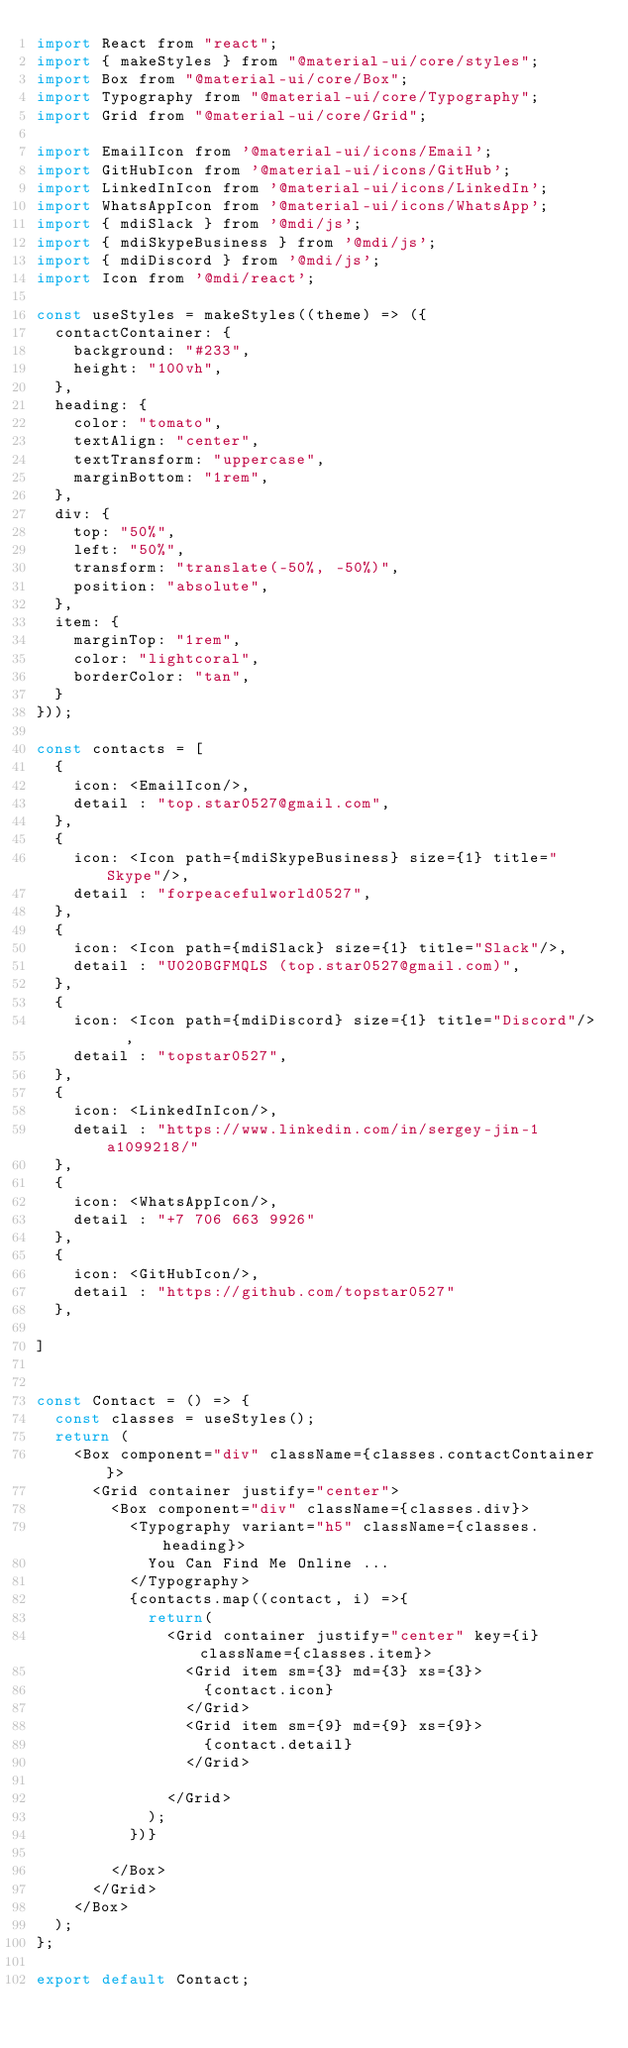<code> <loc_0><loc_0><loc_500><loc_500><_JavaScript_>import React from "react";
import { makeStyles } from "@material-ui/core/styles";
import Box from "@material-ui/core/Box";
import Typography from "@material-ui/core/Typography";
import Grid from "@material-ui/core/Grid";

import EmailIcon from '@material-ui/icons/Email';
import GitHubIcon from '@material-ui/icons/GitHub';
import LinkedInIcon from '@material-ui/icons/LinkedIn';
import WhatsAppIcon from '@material-ui/icons/WhatsApp';
import { mdiSlack } from '@mdi/js';
import { mdiSkypeBusiness } from '@mdi/js';
import { mdiDiscord } from '@mdi/js';
import Icon from '@mdi/react';

const useStyles = makeStyles((theme) => ({
  contactContainer: {
    background: "#233",
    height: "100vh",
  },
  heading: {
    color: "tomato",
    textAlign: "center",
    textTransform: "uppercase",
    marginBottom: "1rem",
  },
  div: {
    top: "50%",
    left: "50%",
    transform: "translate(-50%, -50%)",
    position: "absolute",
  },
  item: {
    marginTop: "1rem",
    color: "lightcoral",
    borderColor: "tan",
  }
}));

const contacts = [
  {
    icon: <EmailIcon/>,
    detail : "top.star0527@gmail.com",
  },
  {
    icon: <Icon path={mdiSkypeBusiness} size={1} title="Skype"/>,
    detail : "forpeacefulworld0527",
  },
  {
    icon: <Icon path={mdiSlack} size={1} title="Slack"/>,
    detail : "U020BGFMQLS (top.star0527@gmail.com)",
  },
  {
    icon: <Icon path={mdiDiscord} size={1} title="Discord"/>  ,
    detail : "topstar0527",
  },
  {
    icon: <LinkedInIcon/>,
    detail : "https://www.linkedin.com/in/sergey-jin-1a1099218/"
  },
  {
    icon: <WhatsAppIcon/>,
    detail : "+7 706 663 9926"
  },
  {
    icon: <GitHubIcon/>,
    detail : "https://github.com/topstar0527"
  },

]


const Contact = () => {
  const classes = useStyles();
  return (
    <Box component="div" className={classes.contactContainer}>
      <Grid container justify="center">
        <Box component="div" className={classes.div}>
          <Typography variant="h5" className={classes.heading}>
            You Can Find Me Online ...
          </Typography>
          {contacts.map((contact, i) =>{
            return(
              <Grid container justify="center" key={i} className={classes.item}>
                <Grid item sm={3} md={3} xs={3}>
                  {contact.icon}
                </Grid>
                <Grid item sm={9} md={9} xs={9}>
                  {contact.detail}
                </Grid>

              </Grid>
            );
          })}
          
        </Box>
      </Grid>
    </Box>
  );
};

export default Contact;
</code> 